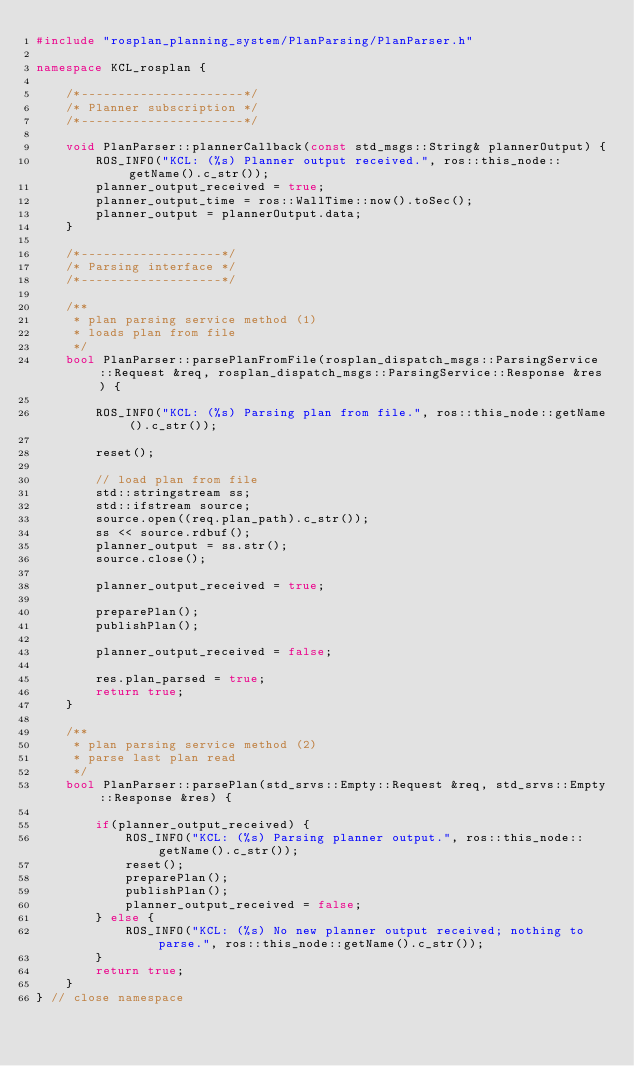<code> <loc_0><loc_0><loc_500><loc_500><_C++_>#include "rosplan_planning_system/PlanParsing/PlanParser.h"

namespace KCL_rosplan {

	/*----------------------*/
	/* Planner subscription */
	/*----------------------*/

	void PlanParser::plannerCallback(const std_msgs::String& plannerOutput) {
		ROS_INFO("KCL: (%s) Planner output received.", ros::this_node::getName().c_str());
		planner_output_received = true;
		planner_output_time = ros::WallTime::now().toSec();
		planner_output = plannerOutput.data;
	}

	/*-------------------*/
	/* Parsing interface */
	/*-------------------*/

	/**
	 * plan parsing service method (1) 
	 * loads plan from file
	 */
	bool PlanParser::parsePlanFromFile(rosplan_dispatch_msgs::ParsingService::Request &req, rosplan_dispatch_msgs::ParsingService::Response &res) {

		ROS_INFO("KCL: (%s) Parsing plan from file.", ros::this_node::getName().c_str());

		reset();

		// load plan from file
		std::stringstream ss;
		std::ifstream source;
		source.open((req.plan_path).c_str());
		ss << source.rdbuf();
		planner_output = ss.str();
		source.close();

		planner_output_received = true;

		preparePlan();
		publishPlan();

		planner_output_received = false;

		res.plan_parsed = true;
		return true;
	}

	/**
	 * plan parsing service method (2) 
	 * parse last plan read
	 */
	bool PlanParser::parsePlan(std_srvs::Empty::Request &req, std_srvs::Empty::Response &res) {

		if(planner_output_received) {
			ROS_INFO("KCL: (%s) Parsing planner output.", ros::this_node::getName().c_str());
			reset();
			preparePlan();
			publishPlan();
			planner_output_received = false;
		} else {
			ROS_INFO("KCL: (%s) No new planner output received; nothing to parse.", ros::this_node::getName().c_str());
		}
		return true;
	}
} // close namespace
</code> 